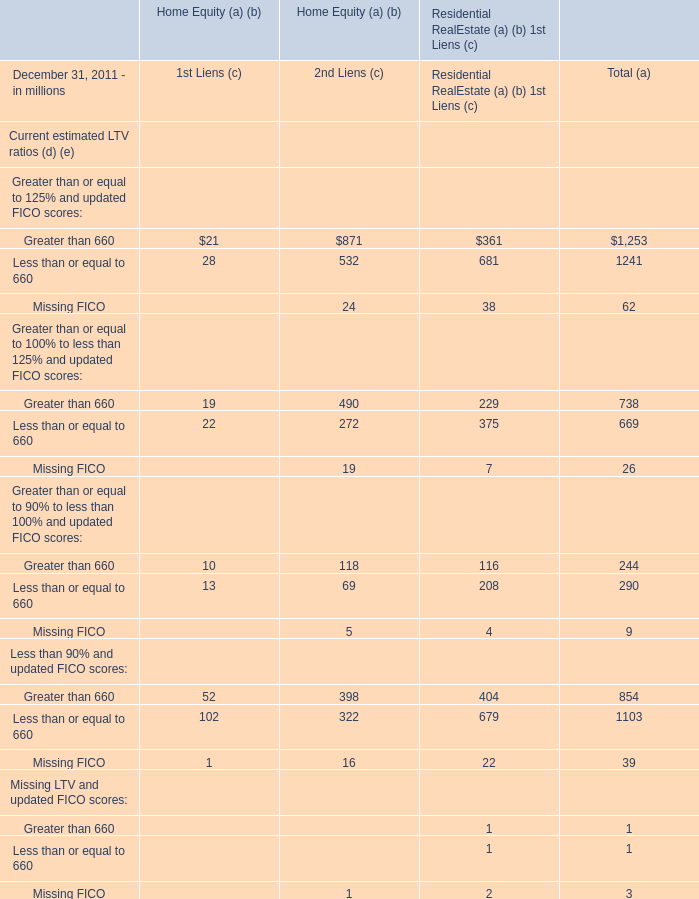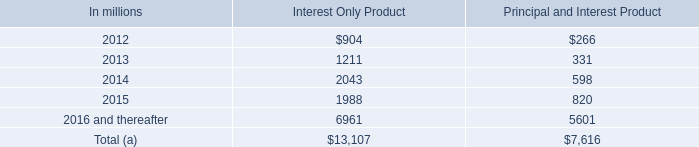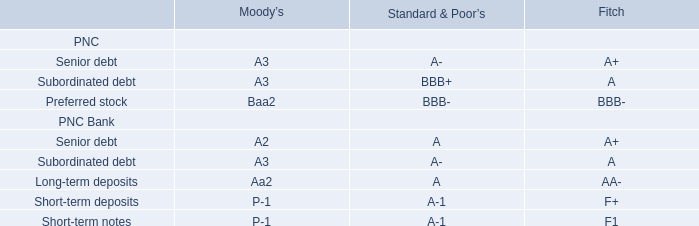What's the total value of all elements that are in the range of 20 and 50 for 1st Liens (c)? (in million) 
Computations: ((21 + 28) + 22)
Answer: 71.0. 